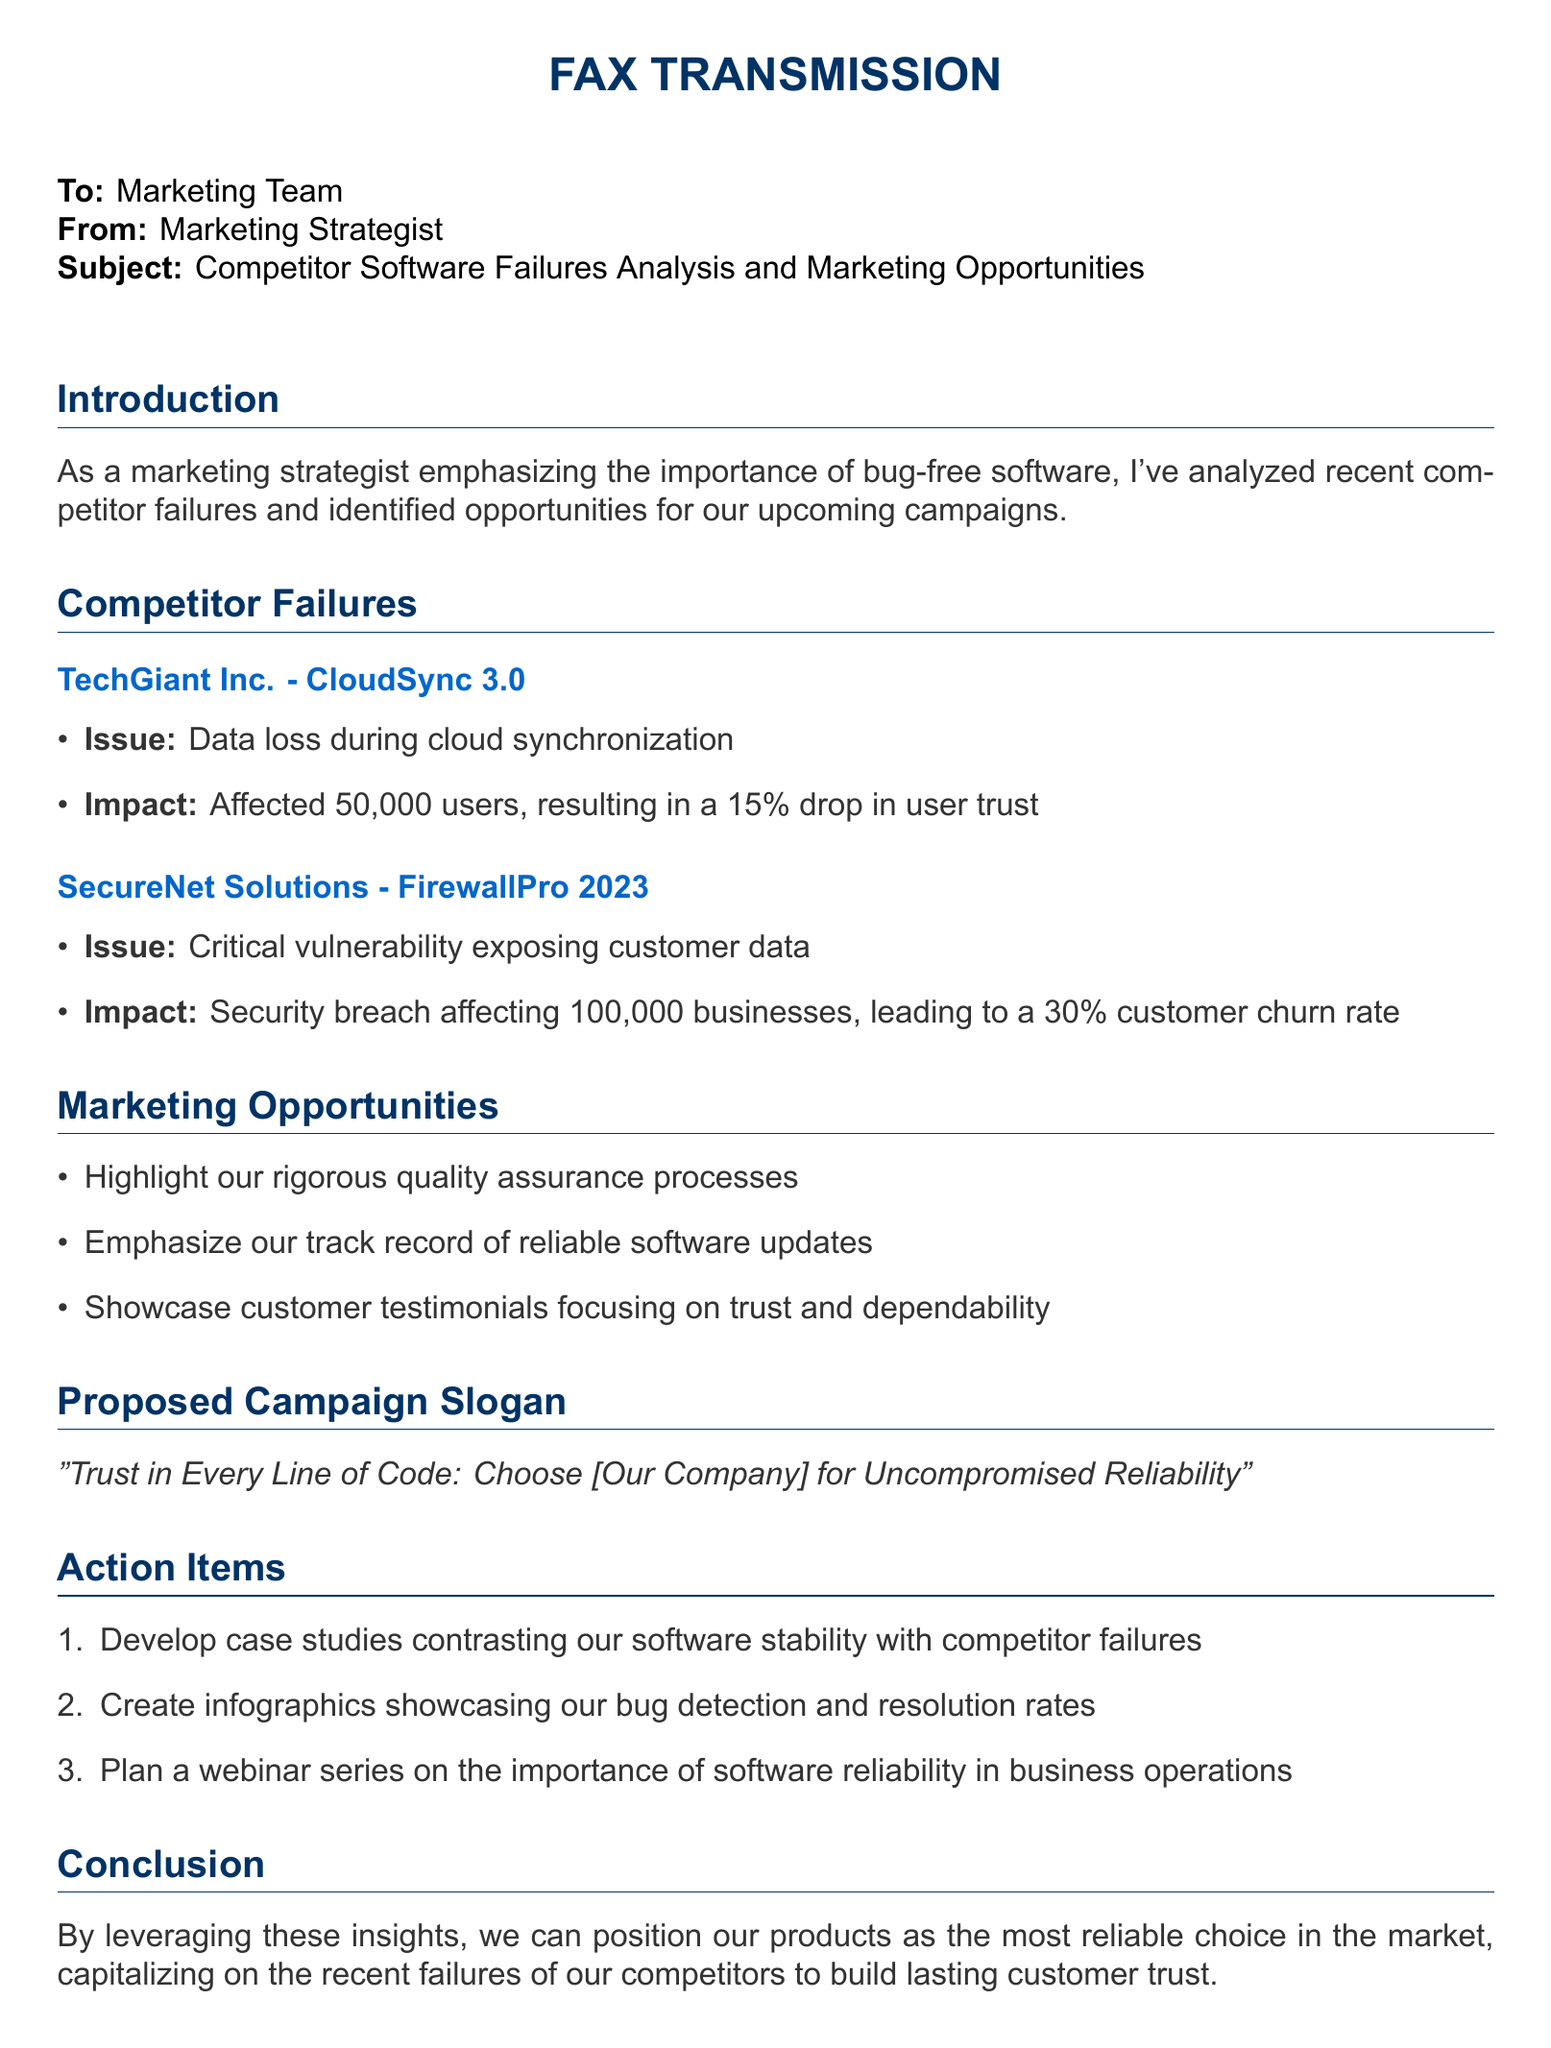What is the issue with TechGiant Inc.'s CloudSync 3.0? The issue is data loss during cloud synchronization.
Answer: Data loss during cloud synchronization What was the impact of SecureNet Solutions' FirewallPro 2023 security breach? The impact was a 30% customer churn rate.
Answer: 30% customer churn rate How many users were affected by TechGiant Inc.'s failure? The number of affected users was 50,000.
Answer: 50,000 What marketing opportunity involves customer testimonials? The opportunity is to showcase customer testimonials focusing on trust and dependability.
Answer: Showcase customer testimonials focusing on trust and dependability What proposed campaign slogan is mentioned in the document? The proposed campaign slogan is "Trust in Every Line of Code: Choose [Our Company] for Uncompromised Reliability".
Answer: "Trust in Every Line of Code: Choose [Our Company] for Uncompromised Reliability" How many action items are proposed in the document? The number of action items proposed is three.
Answer: Three 